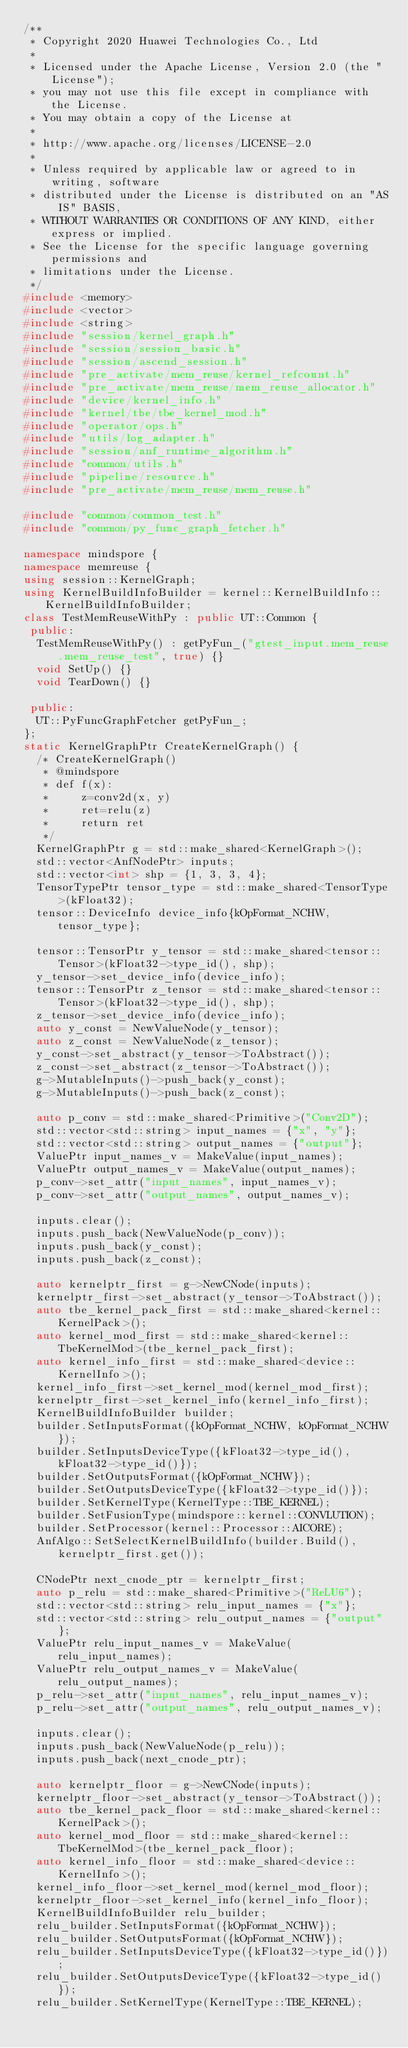<code> <loc_0><loc_0><loc_500><loc_500><_C++_>/**
 * Copyright 2020 Huawei Technologies Co., Ltd
 *
 * Licensed under the Apache License, Version 2.0 (the "License");
 * you may not use this file except in compliance with the License.
 * You may obtain a copy of the License at
 *
 * http://www.apache.org/licenses/LICENSE-2.0
 *
 * Unless required by applicable law or agreed to in writing, software
 * distributed under the License is distributed on an "AS IS" BASIS,
 * WITHOUT WARRANTIES OR CONDITIONS OF ANY KIND, either express or implied.
 * See the License for the specific language governing permissions and
 * limitations under the License.
 */
#include <memory>
#include <vector>
#include <string>
#include "session/kernel_graph.h"
#include "session/session_basic.h"
#include "session/ascend_session.h"
#include "pre_activate/mem_reuse/kernel_refcount.h"
#include "pre_activate/mem_reuse/mem_reuse_allocator.h"
#include "device/kernel_info.h"
#include "kernel/tbe/tbe_kernel_mod.h"
#include "operator/ops.h"
#include "utils/log_adapter.h"
#include "session/anf_runtime_algorithm.h"
#include "common/utils.h"
#include "pipeline/resource.h"
#include "pre_activate/mem_reuse/mem_reuse.h"

#include "common/common_test.h"
#include "common/py_func_graph_fetcher.h"

namespace mindspore {
namespace memreuse {
using session::KernelGraph;
using KernelBuildInfoBuilder = kernel::KernelBuildInfo::KernelBuildInfoBuilder;
class TestMemReuseWithPy : public UT::Common {
 public:
  TestMemReuseWithPy() : getPyFun_("gtest_input.mem_reuse.mem_reuse_test", true) {}
  void SetUp() {}
  void TearDown() {}

 public:
  UT::PyFuncGraphFetcher getPyFun_;
};
static KernelGraphPtr CreateKernelGraph() {
  /* CreateKernelGraph()
   * @mindspore
   * def f(x):
   *     z=conv2d(x, y)
   *     ret=relu(z)
   *     return ret
   */
  KernelGraphPtr g = std::make_shared<KernelGraph>();
  std::vector<AnfNodePtr> inputs;
  std::vector<int> shp = {1, 3, 3, 4};
  TensorTypePtr tensor_type = std::make_shared<TensorType>(kFloat32);
  tensor::DeviceInfo device_info{kOpFormat_NCHW, tensor_type};

  tensor::TensorPtr y_tensor = std::make_shared<tensor::Tensor>(kFloat32->type_id(), shp);
  y_tensor->set_device_info(device_info);
  tensor::TensorPtr z_tensor = std::make_shared<tensor::Tensor>(kFloat32->type_id(), shp);
  z_tensor->set_device_info(device_info);
  auto y_const = NewValueNode(y_tensor);
  auto z_const = NewValueNode(z_tensor);
  y_const->set_abstract(y_tensor->ToAbstract());
  z_const->set_abstract(z_tensor->ToAbstract());
  g->MutableInputs()->push_back(y_const);
  g->MutableInputs()->push_back(z_const);

  auto p_conv = std::make_shared<Primitive>("Conv2D");
  std::vector<std::string> input_names = {"x", "y"};
  std::vector<std::string> output_names = {"output"};
  ValuePtr input_names_v = MakeValue(input_names);
  ValuePtr output_names_v = MakeValue(output_names);
  p_conv->set_attr("input_names", input_names_v);
  p_conv->set_attr("output_names", output_names_v);

  inputs.clear();
  inputs.push_back(NewValueNode(p_conv));
  inputs.push_back(y_const);
  inputs.push_back(z_const);

  auto kernelptr_first = g->NewCNode(inputs);
  kernelptr_first->set_abstract(y_tensor->ToAbstract());
  auto tbe_kernel_pack_first = std::make_shared<kernel::KernelPack>();
  auto kernel_mod_first = std::make_shared<kernel::TbeKernelMod>(tbe_kernel_pack_first);
  auto kernel_info_first = std::make_shared<device::KernelInfo>();
  kernel_info_first->set_kernel_mod(kernel_mod_first);
  kernelptr_first->set_kernel_info(kernel_info_first);
  KernelBuildInfoBuilder builder;
  builder.SetInputsFormat({kOpFormat_NCHW, kOpFormat_NCHW});
  builder.SetInputsDeviceType({kFloat32->type_id(), kFloat32->type_id()});
  builder.SetOutputsFormat({kOpFormat_NCHW});
  builder.SetOutputsDeviceType({kFloat32->type_id()});
  builder.SetKernelType(KernelType::TBE_KERNEL);
  builder.SetFusionType(mindspore::kernel::CONVLUTION);
  builder.SetProcessor(kernel::Processor::AICORE);
  AnfAlgo::SetSelectKernelBuildInfo(builder.Build(), kernelptr_first.get());

  CNodePtr next_cnode_ptr = kernelptr_first;
  auto p_relu = std::make_shared<Primitive>("ReLU6");
  std::vector<std::string> relu_input_names = {"x"};
  std::vector<std::string> relu_output_names = {"output"};
  ValuePtr relu_input_names_v = MakeValue(relu_input_names);
  ValuePtr relu_output_names_v = MakeValue(relu_output_names);
  p_relu->set_attr("input_names", relu_input_names_v);
  p_relu->set_attr("output_names", relu_output_names_v);

  inputs.clear();
  inputs.push_back(NewValueNode(p_relu));
  inputs.push_back(next_cnode_ptr);

  auto kernelptr_floor = g->NewCNode(inputs);
  kernelptr_floor->set_abstract(y_tensor->ToAbstract());
  auto tbe_kernel_pack_floor = std::make_shared<kernel::KernelPack>();
  auto kernel_mod_floor = std::make_shared<kernel::TbeKernelMod>(tbe_kernel_pack_floor);
  auto kernel_info_floor = std::make_shared<device::KernelInfo>();
  kernel_info_floor->set_kernel_mod(kernel_mod_floor);
  kernelptr_floor->set_kernel_info(kernel_info_floor);
  KernelBuildInfoBuilder relu_builder;
  relu_builder.SetInputsFormat({kOpFormat_NCHW});
  relu_builder.SetOutputsFormat({kOpFormat_NCHW});
  relu_builder.SetInputsDeviceType({kFloat32->type_id()});
  relu_builder.SetOutputsDeviceType({kFloat32->type_id()});
  relu_builder.SetKernelType(KernelType::TBE_KERNEL);</code> 